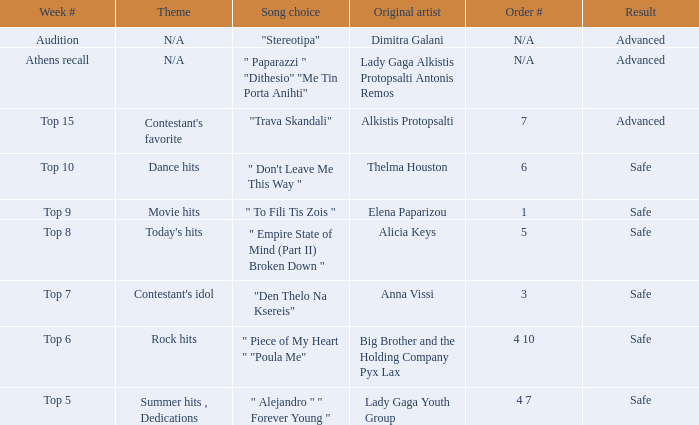Give me the full table as a dictionary. {'header': ['Week #', 'Theme', 'Song choice', 'Original artist', 'Order #', 'Result'], 'rows': [['Audition', 'N/A', '"Stereotipa"', 'Dimitra Galani', 'N/A', 'Advanced'], ['Athens recall', 'N/A', '" Paparazzi " "Dithesio" "Me Tin Porta Anihti"', 'Lady Gaga Alkistis Protopsalti Antonis Remos', 'N/A', 'Advanced'], ['Top 15', "Contestant's favorite", '"Trava Skandali"', 'Alkistis Protopsalti', '7', 'Advanced'], ['Top 10', 'Dance hits', '" Don\'t Leave Me This Way "', 'Thelma Houston', '6', 'Safe'], ['Top 9', 'Movie hits', '" To Fili Tis Zois "', 'Elena Paparizou', '1', 'Safe'], ['Top 8', "Today's hits", '" Empire State of Mind (Part II) Broken Down "', 'Alicia Keys', '5', 'Safe'], ['Top 7', "Contestant's idol", '"Den Thelo Na Ksereis"', 'Anna Vissi', '3', 'Safe'], ['Top 6', 'Rock hits', '" Piece of My Heart " "Poula Me"', 'Big Brother and the Holding Company Pyx Lax', '4 10', 'Safe'], ['Top 5', 'Summer hits , Dedications', '" Alejandro " " Forever Young "', 'Lady Gaga Youth Group', '4 7', 'Safe']]} Which melody was selected during the tryout week? "Stereotipa". 